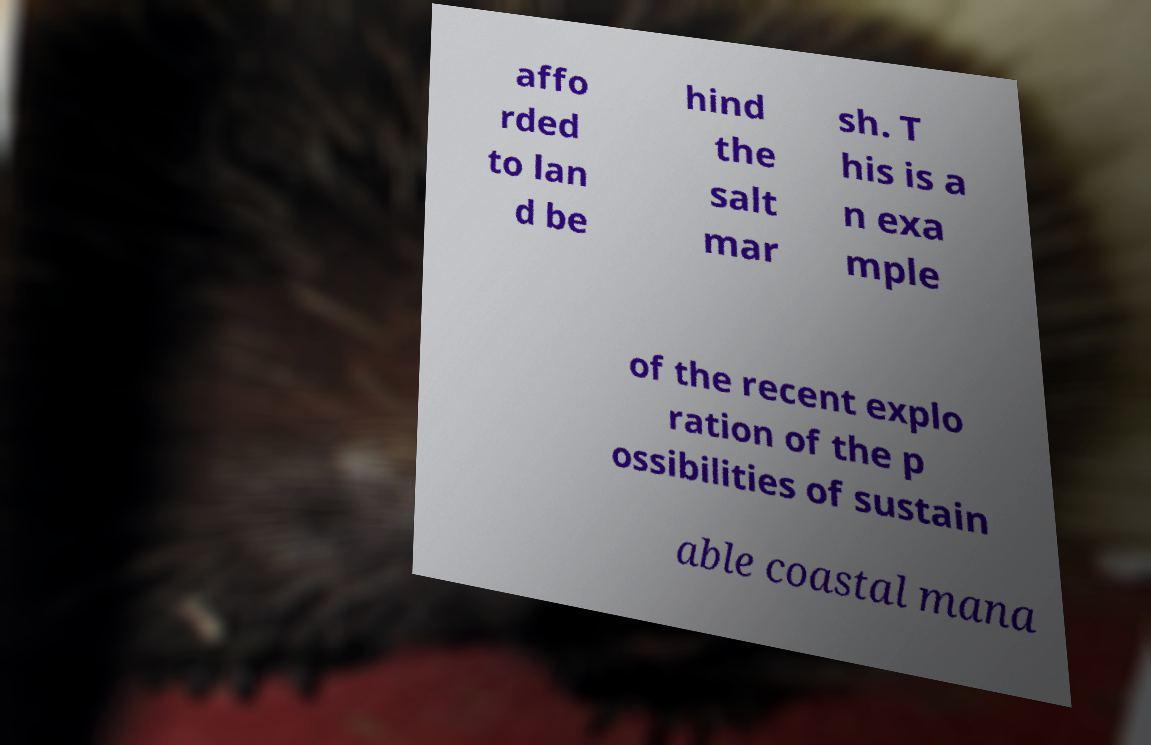There's text embedded in this image that I need extracted. Can you transcribe it verbatim? affo rded to lan d be hind the salt mar sh. T his is a n exa mple of the recent explo ration of the p ossibilities of sustain able coastal mana 